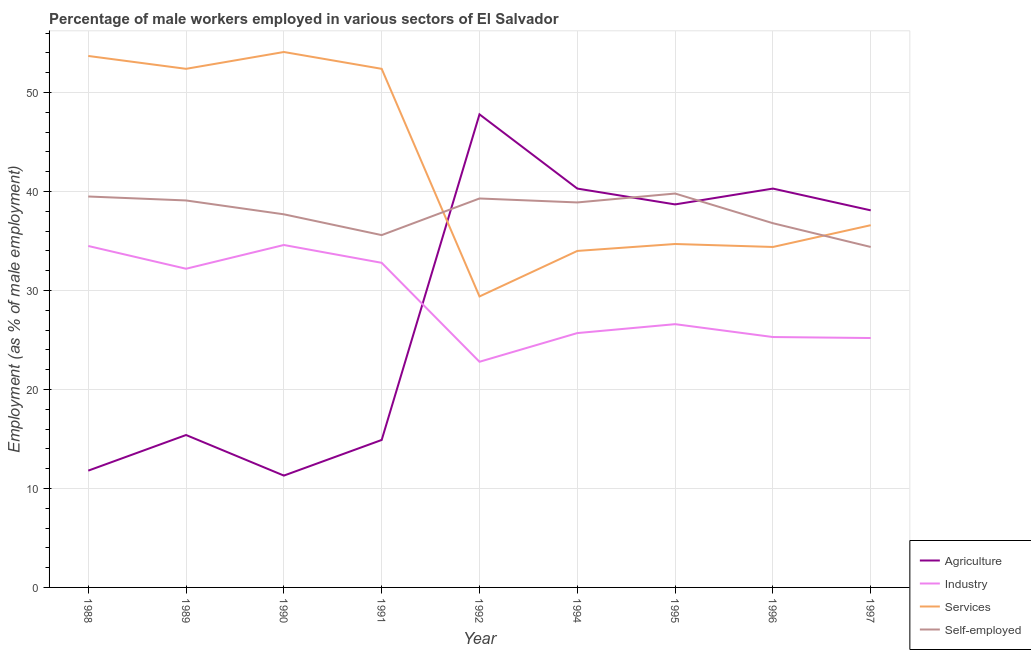How many different coloured lines are there?
Provide a succinct answer. 4. Does the line corresponding to percentage of male workers in services intersect with the line corresponding to percentage of self employed male workers?
Provide a short and direct response. Yes. Is the number of lines equal to the number of legend labels?
Offer a very short reply. Yes. What is the percentage of male workers in services in 1988?
Give a very brief answer. 53.7. Across all years, what is the maximum percentage of self employed male workers?
Provide a succinct answer. 39.8. Across all years, what is the minimum percentage of male workers in agriculture?
Provide a short and direct response. 11.3. In which year was the percentage of male workers in industry maximum?
Provide a short and direct response. 1990. In which year was the percentage of male workers in agriculture minimum?
Provide a succinct answer. 1990. What is the total percentage of self employed male workers in the graph?
Give a very brief answer. 341.1. What is the difference between the percentage of male workers in services in 1990 and that in 1996?
Offer a very short reply. 19.7. What is the difference between the percentage of male workers in agriculture in 1996 and the percentage of male workers in services in 1995?
Your response must be concise. 5.6. What is the average percentage of male workers in industry per year?
Make the answer very short. 28.86. In the year 1990, what is the difference between the percentage of self employed male workers and percentage of male workers in agriculture?
Offer a very short reply. 26.4. What is the ratio of the percentage of self employed male workers in 1991 to that in 1994?
Give a very brief answer. 0.92. What is the difference between the highest and the second highest percentage of male workers in services?
Provide a succinct answer. 0.4. What is the difference between the highest and the lowest percentage of male workers in services?
Give a very brief answer. 24.7. Is the sum of the percentage of male workers in industry in 1989 and 1996 greater than the maximum percentage of self employed male workers across all years?
Ensure brevity in your answer.  Yes. Is it the case that in every year, the sum of the percentage of self employed male workers and percentage of male workers in services is greater than the sum of percentage of male workers in industry and percentage of male workers in agriculture?
Your answer should be very brief. Yes. Does the percentage of male workers in services monotonically increase over the years?
Offer a very short reply. No. How many lines are there?
Ensure brevity in your answer.  4. Does the graph contain any zero values?
Provide a short and direct response. No. Does the graph contain grids?
Keep it short and to the point. Yes. Where does the legend appear in the graph?
Your answer should be compact. Bottom right. How many legend labels are there?
Offer a very short reply. 4. What is the title of the graph?
Your answer should be very brief. Percentage of male workers employed in various sectors of El Salvador. What is the label or title of the X-axis?
Your answer should be very brief. Year. What is the label or title of the Y-axis?
Your answer should be compact. Employment (as % of male employment). What is the Employment (as % of male employment) in Agriculture in 1988?
Your response must be concise. 11.8. What is the Employment (as % of male employment) in Industry in 1988?
Offer a terse response. 34.5. What is the Employment (as % of male employment) of Services in 1988?
Provide a short and direct response. 53.7. What is the Employment (as % of male employment) of Self-employed in 1988?
Give a very brief answer. 39.5. What is the Employment (as % of male employment) in Agriculture in 1989?
Your response must be concise. 15.4. What is the Employment (as % of male employment) in Industry in 1989?
Offer a very short reply. 32.2. What is the Employment (as % of male employment) of Services in 1989?
Your answer should be very brief. 52.4. What is the Employment (as % of male employment) in Self-employed in 1989?
Your response must be concise. 39.1. What is the Employment (as % of male employment) in Agriculture in 1990?
Keep it short and to the point. 11.3. What is the Employment (as % of male employment) in Industry in 1990?
Ensure brevity in your answer.  34.6. What is the Employment (as % of male employment) of Services in 1990?
Your answer should be very brief. 54.1. What is the Employment (as % of male employment) of Self-employed in 1990?
Offer a very short reply. 37.7. What is the Employment (as % of male employment) of Agriculture in 1991?
Your answer should be compact. 14.9. What is the Employment (as % of male employment) of Industry in 1991?
Make the answer very short. 32.8. What is the Employment (as % of male employment) of Services in 1991?
Give a very brief answer. 52.4. What is the Employment (as % of male employment) of Self-employed in 1991?
Offer a terse response. 35.6. What is the Employment (as % of male employment) of Agriculture in 1992?
Provide a succinct answer. 47.8. What is the Employment (as % of male employment) in Industry in 1992?
Provide a succinct answer. 22.8. What is the Employment (as % of male employment) of Services in 1992?
Your response must be concise. 29.4. What is the Employment (as % of male employment) in Self-employed in 1992?
Offer a terse response. 39.3. What is the Employment (as % of male employment) in Agriculture in 1994?
Make the answer very short. 40.3. What is the Employment (as % of male employment) of Industry in 1994?
Give a very brief answer. 25.7. What is the Employment (as % of male employment) in Services in 1994?
Give a very brief answer. 34. What is the Employment (as % of male employment) in Self-employed in 1994?
Your answer should be compact. 38.9. What is the Employment (as % of male employment) of Agriculture in 1995?
Provide a succinct answer. 38.7. What is the Employment (as % of male employment) of Industry in 1995?
Your response must be concise. 26.6. What is the Employment (as % of male employment) in Services in 1995?
Make the answer very short. 34.7. What is the Employment (as % of male employment) in Self-employed in 1995?
Provide a short and direct response. 39.8. What is the Employment (as % of male employment) of Agriculture in 1996?
Give a very brief answer. 40.3. What is the Employment (as % of male employment) of Industry in 1996?
Your answer should be compact. 25.3. What is the Employment (as % of male employment) in Services in 1996?
Make the answer very short. 34.4. What is the Employment (as % of male employment) in Self-employed in 1996?
Keep it short and to the point. 36.8. What is the Employment (as % of male employment) of Agriculture in 1997?
Make the answer very short. 38.1. What is the Employment (as % of male employment) of Industry in 1997?
Your answer should be compact. 25.2. What is the Employment (as % of male employment) in Services in 1997?
Make the answer very short. 36.6. What is the Employment (as % of male employment) of Self-employed in 1997?
Offer a very short reply. 34.4. Across all years, what is the maximum Employment (as % of male employment) in Agriculture?
Offer a terse response. 47.8. Across all years, what is the maximum Employment (as % of male employment) of Industry?
Provide a succinct answer. 34.6. Across all years, what is the maximum Employment (as % of male employment) in Services?
Ensure brevity in your answer.  54.1. Across all years, what is the maximum Employment (as % of male employment) in Self-employed?
Provide a succinct answer. 39.8. Across all years, what is the minimum Employment (as % of male employment) in Agriculture?
Your response must be concise. 11.3. Across all years, what is the minimum Employment (as % of male employment) of Industry?
Give a very brief answer. 22.8. Across all years, what is the minimum Employment (as % of male employment) of Services?
Provide a succinct answer. 29.4. Across all years, what is the minimum Employment (as % of male employment) in Self-employed?
Your response must be concise. 34.4. What is the total Employment (as % of male employment) in Agriculture in the graph?
Make the answer very short. 258.6. What is the total Employment (as % of male employment) in Industry in the graph?
Give a very brief answer. 259.7. What is the total Employment (as % of male employment) in Services in the graph?
Provide a short and direct response. 381.7. What is the total Employment (as % of male employment) in Self-employed in the graph?
Provide a short and direct response. 341.1. What is the difference between the Employment (as % of male employment) in Industry in 1988 and that in 1989?
Provide a succinct answer. 2.3. What is the difference between the Employment (as % of male employment) in Agriculture in 1988 and that in 1990?
Offer a very short reply. 0.5. What is the difference between the Employment (as % of male employment) of Services in 1988 and that in 1990?
Provide a short and direct response. -0.4. What is the difference between the Employment (as % of male employment) in Self-employed in 1988 and that in 1990?
Provide a succinct answer. 1.8. What is the difference between the Employment (as % of male employment) in Agriculture in 1988 and that in 1991?
Your answer should be compact. -3.1. What is the difference between the Employment (as % of male employment) of Industry in 1988 and that in 1991?
Keep it short and to the point. 1.7. What is the difference between the Employment (as % of male employment) in Services in 1988 and that in 1991?
Offer a very short reply. 1.3. What is the difference between the Employment (as % of male employment) of Self-employed in 1988 and that in 1991?
Provide a succinct answer. 3.9. What is the difference between the Employment (as % of male employment) in Agriculture in 1988 and that in 1992?
Your response must be concise. -36. What is the difference between the Employment (as % of male employment) in Industry in 1988 and that in 1992?
Provide a short and direct response. 11.7. What is the difference between the Employment (as % of male employment) in Services in 1988 and that in 1992?
Offer a terse response. 24.3. What is the difference between the Employment (as % of male employment) in Self-employed in 1988 and that in 1992?
Offer a terse response. 0.2. What is the difference between the Employment (as % of male employment) in Agriculture in 1988 and that in 1994?
Offer a terse response. -28.5. What is the difference between the Employment (as % of male employment) in Agriculture in 1988 and that in 1995?
Keep it short and to the point. -26.9. What is the difference between the Employment (as % of male employment) of Agriculture in 1988 and that in 1996?
Provide a short and direct response. -28.5. What is the difference between the Employment (as % of male employment) of Services in 1988 and that in 1996?
Make the answer very short. 19.3. What is the difference between the Employment (as % of male employment) in Agriculture in 1988 and that in 1997?
Make the answer very short. -26.3. What is the difference between the Employment (as % of male employment) of Services in 1988 and that in 1997?
Your answer should be very brief. 17.1. What is the difference between the Employment (as % of male employment) of Self-employed in 1988 and that in 1997?
Your answer should be very brief. 5.1. What is the difference between the Employment (as % of male employment) in Agriculture in 1989 and that in 1990?
Make the answer very short. 4.1. What is the difference between the Employment (as % of male employment) in Industry in 1989 and that in 1990?
Your response must be concise. -2.4. What is the difference between the Employment (as % of male employment) of Agriculture in 1989 and that in 1991?
Provide a succinct answer. 0.5. What is the difference between the Employment (as % of male employment) in Agriculture in 1989 and that in 1992?
Provide a short and direct response. -32.4. What is the difference between the Employment (as % of male employment) in Services in 1989 and that in 1992?
Keep it short and to the point. 23. What is the difference between the Employment (as % of male employment) in Agriculture in 1989 and that in 1994?
Give a very brief answer. -24.9. What is the difference between the Employment (as % of male employment) in Industry in 1989 and that in 1994?
Your answer should be compact. 6.5. What is the difference between the Employment (as % of male employment) of Services in 1989 and that in 1994?
Make the answer very short. 18.4. What is the difference between the Employment (as % of male employment) in Self-employed in 1989 and that in 1994?
Make the answer very short. 0.2. What is the difference between the Employment (as % of male employment) of Agriculture in 1989 and that in 1995?
Ensure brevity in your answer.  -23.3. What is the difference between the Employment (as % of male employment) of Industry in 1989 and that in 1995?
Make the answer very short. 5.6. What is the difference between the Employment (as % of male employment) in Services in 1989 and that in 1995?
Your response must be concise. 17.7. What is the difference between the Employment (as % of male employment) in Self-employed in 1989 and that in 1995?
Offer a terse response. -0.7. What is the difference between the Employment (as % of male employment) in Agriculture in 1989 and that in 1996?
Offer a very short reply. -24.9. What is the difference between the Employment (as % of male employment) in Agriculture in 1989 and that in 1997?
Give a very brief answer. -22.7. What is the difference between the Employment (as % of male employment) of Services in 1989 and that in 1997?
Make the answer very short. 15.8. What is the difference between the Employment (as % of male employment) of Agriculture in 1990 and that in 1991?
Keep it short and to the point. -3.6. What is the difference between the Employment (as % of male employment) in Industry in 1990 and that in 1991?
Your answer should be very brief. 1.8. What is the difference between the Employment (as % of male employment) in Services in 1990 and that in 1991?
Your answer should be very brief. 1.7. What is the difference between the Employment (as % of male employment) in Agriculture in 1990 and that in 1992?
Give a very brief answer. -36.5. What is the difference between the Employment (as % of male employment) in Services in 1990 and that in 1992?
Give a very brief answer. 24.7. What is the difference between the Employment (as % of male employment) of Self-employed in 1990 and that in 1992?
Your answer should be compact. -1.6. What is the difference between the Employment (as % of male employment) of Industry in 1990 and that in 1994?
Make the answer very short. 8.9. What is the difference between the Employment (as % of male employment) in Services in 1990 and that in 1994?
Give a very brief answer. 20.1. What is the difference between the Employment (as % of male employment) in Self-employed in 1990 and that in 1994?
Provide a short and direct response. -1.2. What is the difference between the Employment (as % of male employment) of Agriculture in 1990 and that in 1995?
Provide a short and direct response. -27.4. What is the difference between the Employment (as % of male employment) of Services in 1990 and that in 1995?
Give a very brief answer. 19.4. What is the difference between the Employment (as % of male employment) in Agriculture in 1990 and that in 1996?
Ensure brevity in your answer.  -29. What is the difference between the Employment (as % of male employment) of Services in 1990 and that in 1996?
Offer a very short reply. 19.7. What is the difference between the Employment (as % of male employment) of Agriculture in 1990 and that in 1997?
Offer a very short reply. -26.8. What is the difference between the Employment (as % of male employment) in Industry in 1990 and that in 1997?
Your answer should be compact. 9.4. What is the difference between the Employment (as % of male employment) of Agriculture in 1991 and that in 1992?
Give a very brief answer. -32.9. What is the difference between the Employment (as % of male employment) in Services in 1991 and that in 1992?
Your answer should be compact. 23. What is the difference between the Employment (as % of male employment) in Self-employed in 1991 and that in 1992?
Give a very brief answer. -3.7. What is the difference between the Employment (as % of male employment) of Agriculture in 1991 and that in 1994?
Give a very brief answer. -25.4. What is the difference between the Employment (as % of male employment) in Industry in 1991 and that in 1994?
Give a very brief answer. 7.1. What is the difference between the Employment (as % of male employment) in Agriculture in 1991 and that in 1995?
Your answer should be compact. -23.8. What is the difference between the Employment (as % of male employment) in Industry in 1991 and that in 1995?
Ensure brevity in your answer.  6.2. What is the difference between the Employment (as % of male employment) of Agriculture in 1991 and that in 1996?
Offer a terse response. -25.4. What is the difference between the Employment (as % of male employment) of Industry in 1991 and that in 1996?
Offer a terse response. 7.5. What is the difference between the Employment (as % of male employment) of Services in 1991 and that in 1996?
Provide a short and direct response. 18. What is the difference between the Employment (as % of male employment) in Agriculture in 1991 and that in 1997?
Keep it short and to the point. -23.2. What is the difference between the Employment (as % of male employment) of Agriculture in 1992 and that in 1994?
Provide a succinct answer. 7.5. What is the difference between the Employment (as % of male employment) of Self-employed in 1992 and that in 1994?
Your answer should be very brief. 0.4. What is the difference between the Employment (as % of male employment) in Agriculture in 1992 and that in 1995?
Your answer should be compact. 9.1. What is the difference between the Employment (as % of male employment) in Industry in 1992 and that in 1995?
Your response must be concise. -3.8. What is the difference between the Employment (as % of male employment) of Self-employed in 1992 and that in 1995?
Ensure brevity in your answer.  -0.5. What is the difference between the Employment (as % of male employment) in Agriculture in 1992 and that in 1996?
Your answer should be very brief. 7.5. What is the difference between the Employment (as % of male employment) of Industry in 1992 and that in 1997?
Keep it short and to the point. -2.4. What is the difference between the Employment (as % of male employment) in Services in 1992 and that in 1997?
Provide a short and direct response. -7.2. What is the difference between the Employment (as % of male employment) of Industry in 1994 and that in 1995?
Give a very brief answer. -0.9. What is the difference between the Employment (as % of male employment) of Services in 1994 and that in 1995?
Your answer should be compact. -0.7. What is the difference between the Employment (as % of male employment) of Self-employed in 1994 and that in 1996?
Make the answer very short. 2.1. What is the difference between the Employment (as % of male employment) in Agriculture in 1994 and that in 1997?
Make the answer very short. 2.2. What is the difference between the Employment (as % of male employment) of Services in 1994 and that in 1997?
Keep it short and to the point. -2.6. What is the difference between the Employment (as % of male employment) in Self-employed in 1994 and that in 1997?
Provide a succinct answer. 4.5. What is the difference between the Employment (as % of male employment) of Agriculture in 1995 and that in 1996?
Ensure brevity in your answer.  -1.6. What is the difference between the Employment (as % of male employment) of Industry in 1995 and that in 1996?
Your answer should be compact. 1.3. What is the difference between the Employment (as % of male employment) of Self-employed in 1995 and that in 1996?
Give a very brief answer. 3. What is the difference between the Employment (as % of male employment) of Industry in 1995 and that in 1997?
Offer a very short reply. 1.4. What is the difference between the Employment (as % of male employment) of Industry in 1996 and that in 1997?
Your answer should be compact. 0.1. What is the difference between the Employment (as % of male employment) in Self-employed in 1996 and that in 1997?
Your answer should be compact. 2.4. What is the difference between the Employment (as % of male employment) of Agriculture in 1988 and the Employment (as % of male employment) of Industry in 1989?
Your answer should be compact. -20.4. What is the difference between the Employment (as % of male employment) in Agriculture in 1988 and the Employment (as % of male employment) in Services in 1989?
Offer a terse response. -40.6. What is the difference between the Employment (as % of male employment) in Agriculture in 1988 and the Employment (as % of male employment) in Self-employed in 1989?
Ensure brevity in your answer.  -27.3. What is the difference between the Employment (as % of male employment) of Industry in 1988 and the Employment (as % of male employment) of Services in 1989?
Give a very brief answer. -17.9. What is the difference between the Employment (as % of male employment) in Industry in 1988 and the Employment (as % of male employment) in Self-employed in 1989?
Make the answer very short. -4.6. What is the difference between the Employment (as % of male employment) in Services in 1988 and the Employment (as % of male employment) in Self-employed in 1989?
Ensure brevity in your answer.  14.6. What is the difference between the Employment (as % of male employment) in Agriculture in 1988 and the Employment (as % of male employment) in Industry in 1990?
Keep it short and to the point. -22.8. What is the difference between the Employment (as % of male employment) in Agriculture in 1988 and the Employment (as % of male employment) in Services in 1990?
Provide a succinct answer. -42.3. What is the difference between the Employment (as % of male employment) of Agriculture in 1988 and the Employment (as % of male employment) of Self-employed in 1990?
Offer a very short reply. -25.9. What is the difference between the Employment (as % of male employment) in Industry in 1988 and the Employment (as % of male employment) in Services in 1990?
Make the answer very short. -19.6. What is the difference between the Employment (as % of male employment) of Industry in 1988 and the Employment (as % of male employment) of Self-employed in 1990?
Your answer should be compact. -3.2. What is the difference between the Employment (as % of male employment) in Services in 1988 and the Employment (as % of male employment) in Self-employed in 1990?
Your answer should be very brief. 16. What is the difference between the Employment (as % of male employment) of Agriculture in 1988 and the Employment (as % of male employment) of Services in 1991?
Keep it short and to the point. -40.6. What is the difference between the Employment (as % of male employment) in Agriculture in 1988 and the Employment (as % of male employment) in Self-employed in 1991?
Provide a short and direct response. -23.8. What is the difference between the Employment (as % of male employment) in Industry in 1988 and the Employment (as % of male employment) in Services in 1991?
Ensure brevity in your answer.  -17.9. What is the difference between the Employment (as % of male employment) in Industry in 1988 and the Employment (as % of male employment) in Self-employed in 1991?
Offer a very short reply. -1.1. What is the difference between the Employment (as % of male employment) of Services in 1988 and the Employment (as % of male employment) of Self-employed in 1991?
Ensure brevity in your answer.  18.1. What is the difference between the Employment (as % of male employment) in Agriculture in 1988 and the Employment (as % of male employment) in Industry in 1992?
Your answer should be compact. -11. What is the difference between the Employment (as % of male employment) of Agriculture in 1988 and the Employment (as % of male employment) of Services in 1992?
Offer a very short reply. -17.6. What is the difference between the Employment (as % of male employment) of Agriculture in 1988 and the Employment (as % of male employment) of Self-employed in 1992?
Make the answer very short. -27.5. What is the difference between the Employment (as % of male employment) of Industry in 1988 and the Employment (as % of male employment) of Self-employed in 1992?
Offer a very short reply. -4.8. What is the difference between the Employment (as % of male employment) in Services in 1988 and the Employment (as % of male employment) in Self-employed in 1992?
Offer a terse response. 14.4. What is the difference between the Employment (as % of male employment) in Agriculture in 1988 and the Employment (as % of male employment) in Services in 1994?
Your response must be concise. -22.2. What is the difference between the Employment (as % of male employment) of Agriculture in 1988 and the Employment (as % of male employment) of Self-employed in 1994?
Keep it short and to the point. -27.1. What is the difference between the Employment (as % of male employment) of Industry in 1988 and the Employment (as % of male employment) of Self-employed in 1994?
Your answer should be compact. -4.4. What is the difference between the Employment (as % of male employment) of Agriculture in 1988 and the Employment (as % of male employment) of Industry in 1995?
Make the answer very short. -14.8. What is the difference between the Employment (as % of male employment) of Agriculture in 1988 and the Employment (as % of male employment) of Services in 1995?
Ensure brevity in your answer.  -22.9. What is the difference between the Employment (as % of male employment) of Agriculture in 1988 and the Employment (as % of male employment) of Self-employed in 1995?
Your answer should be compact. -28. What is the difference between the Employment (as % of male employment) of Industry in 1988 and the Employment (as % of male employment) of Services in 1995?
Offer a terse response. -0.2. What is the difference between the Employment (as % of male employment) of Agriculture in 1988 and the Employment (as % of male employment) of Industry in 1996?
Offer a very short reply. -13.5. What is the difference between the Employment (as % of male employment) of Agriculture in 1988 and the Employment (as % of male employment) of Services in 1996?
Keep it short and to the point. -22.6. What is the difference between the Employment (as % of male employment) in Agriculture in 1988 and the Employment (as % of male employment) in Self-employed in 1996?
Your answer should be compact. -25. What is the difference between the Employment (as % of male employment) of Industry in 1988 and the Employment (as % of male employment) of Services in 1996?
Your response must be concise. 0.1. What is the difference between the Employment (as % of male employment) of Services in 1988 and the Employment (as % of male employment) of Self-employed in 1996?
Your answer should be very brief. 16.9. What is the difference between the Employment (as % of male employment) in Agriculture in 1988 and the Employment (as % of male employment) in Industry in 1997?
Provide a succinct answer. -13.4. What is the difference between the Employment (as % of male employment) in Agriculture in 1988 and the Employment (as % of male employment) in Services in 1997?
Your answer should be very brief. -24.8. What is the difference between the Employment (as % of male employment) of Agriculture in 1988 and the Employment (as % of male employment) of Self-employed in 1997?
Offer a terse response. -22.6. What is the difference between the Employment (as % of male employment) of Services in 1988 and the Employment (as % of male employment) of Self-employed in 1997?
Provide a succinct answer. 19.3. What is the difference between the Employment (as % of male employment) of Agriculture in 1989 and the Employment (as % of male employment) of Industry in 1990?
Make the answer very short. -19.2. What is the difference between the Employment (as % of male employment) of Agriculture in 1989 and the Employment (as % of male employment) of Services in 1990?
Give a very brief answer. -38.7. What is the difference between the Employment (as % of male employment) in Agriculture in 1989 and the Employment (as % of male employment) in Self-employed in 1990?
Your answer should be compact. -22.3. What is the difference between the Employment (as % of male employment) of Industry in 1989 and the Employment (as % of male employment) of Services in 1990?
Provide a short and direct response. -21.9. What is the difference between the Employment (as % of male employment) in Industry in 1989 and the Employment (as % of male employment) in Self-employed in 1990?
Provide a short and direct response. -5.5. What is the difference between the Employment (as % of male employment) in Services in 1989 and the Employment (as % of male employment) in Self-employed in 1990?
Ensure brevity in your answer.  14.7. What is the difference between the Employment (as % of male employment) of Agriculture in 1989 and the Employment (as % of male employment) of Industry in 1991?
Provide a succinct answer. -17.4. What is the difference between the Employment (as % of male employment) in Agriculture in 1989 and the Employment (as % of male employment) in Services in 1991?
Your answer should be compact. -37. What is the difference between the Employment (as % of male employment) in Agriculture in 1989 and the Employment (as % of male employment) in Self-employed in 1991?
Keep it short and to the point. -20.2. What is the difference between the Employment (as % of male employment) of Industry in 1989 and the Employment (as % of male employment) of Services in 1991?
Your response must be concise. -20.2. What is the difference between the Employment (as % of male employment) of Industry in 1989 and the Employment (as % of male employment) of Self-employed in 1991?
Offer a very short reply. -3.4. What is the difference between the Employment (as % of male employment) of Agriculture in 1989 and the Employment (as % of male employment) of Industry in 1992?
Your response must be concise. -7.4. What is the difference between the Employment (as % of male employment) in Agriculture in 1989 and the Employment (as % of male employment) in Services in 1992?
Keep it short and to the point. -14. What is the difference between the Employment (as % of male employment) of Agriculture in 1989 and the Employment (as % of male employment) of Self-employed in 1992?
Keep it short and to the point. -23.9. What is the difference between the Employment (as % of male employment) of Industry in 1989 and the Employment (as % of male employment) of Self-employed in 1992?
Give a very brief answer. -7.1. What is the difference between the Employment (as % of male employment) of Agriculture in 1989 and the Employment (as % of male employment) of Services in 1994?
Make the answer very short. -18.6. What is the difference between the Employment (as % of male employment) in Agriculture in 1989 and the Employment (as % of male employment) in Self-employed in 1994?
Ensure brevity in your answer.  -23.5. What is the difference between the Employment (as % of male employment) of Industry in 1989 and the Employment (as % of male employment) of Self-employed in 1994?
Your response must be concise. -6.7. What is the difference between the Employment (as % of male employment) of Services in 1989 and the Employment (as % of male employment) of Self-employed in 1994?
Ensure brevity in your answer.  13.5. What is the difference between the Employment (as % of male employment) in Agriculture in 1989 and the Employment (as % of male employment) in Industry in 1995?
Make the answer very short. -11.2. What is the difference between the Employment (as % of male employment) of Agriculture in 1989 and the Employment (as % of male employment) of Services in 1995?
Ensure brevity in your answer.  -19.3. What is the difference between the Employment (as % of male employment) of Agriculture in 1989 and the Employment (as % of male employment) of Self-employed in 1995?
Ensure brevity in your answer.  -24.4. What is the difference between the Employment (as % of male employment) in Industry in 1989 and the Employment (as % of male employment) in Services in 1995?
Make the answer very short. -2.5. What is the difference between the Employment (as % of male employment) of Industry in 1989 and the Employment (as % of male employment) of Self-employed in 1995?
Keep it short and to the point. -7.6. What is the difference between the Employment (as % of male employment) of Services in 1989 and the Employment (as % of male employment) of Self-employed in 1995?
Offer a terse response. 12.6. What is the difference between the Employment (as % of male employment) of Agriculture in 1989 and the Employment (as % of male employment) of Self-employed in 1996?
Provide a succinct answer. -21.4. What is the difference between the Employment (as % of male employment) in Industry in 1989 and the Employment (as % of male employment) in Services in 1996?
Your response must be concise. -2.2. What is the difference between the Employment (as % of male employment) in Agriculture in 1989 and the Employment (as % of male employment) in Services in 1997?
Make the answer very short. -21.2. What is the difference between the Employment (as % of male employment) in Agriculture in 1989 and the Employment (as % of male employment) in Self-employed in 1997?
Give a very brief answer. -19. What is the difference between the Employment (as % of male employment) in Agriculture in 1990 and the Employment (as % of male employment) in Industry in 1991?
Offer a very short reply. -21.5. What is the difference between the Employment (as % of male employment) in Agriculture in 1990 and the Employment (as % of male employment) in Services in 1991?
Your answer should be compact. -41.1. What is the difference between the Employment (as % of male employment) in Agriculture in 1990 and the Employment (as % of male employment) in Self-employed in 1991?
Your answer should be very brief. -24.3. What is the difference between the Employment (as % of male employment) in Industry in 1990 and the Employment (as % of male employment) in Services in 1991?
Your response must be concise. -17.8. What is the difference between the Employment (as % of male employment) of Services in 1990 and the Employment (as % of male employment) of Self-employed in 1991?
Offer a terse response. 18.5. What is the difference between the Employment (as % of male employment) of Agriculture in 1990 and the Employment (as % of male employment) of Industry in 1992?
Make the answer very short. -11.5. What is the difference between the Employment (as % of male employment) in Agriculture in 1990 and the Employment (as % of male employment) in Services in 1992?
Offer a terse response. -18.1. What is the difference between the Employment (as % of male employment) in Agriculture in 1990 and the Employment (as % of male employment) in Self-employed in 1992?
Offer a terse response. -28. What is the difference between the Employment (as % of male employment) of Industry in 1990 and the Employment (as % of male employment) of Services in 1992?
Offer a terse response. 5.2. What is the difference between the Employment (as % of male employment) in Agriculture in 1990 and the Employment (as % of male employment) in Industry in 1994?
Your response must be concise. -14.4. What is the difference between the Employment (as % of male employment) in Agriculture in 1990 and the Employment (as % of male employment) in Services in 1994?
Give a very brief answer. -22.7. What is the difference between the Employment (as % of male employment) in Agriculture in 1990 and the Employment (as % of male employment) in Self-employed in 1994?
Offer a terse response. -27.6. What is the difference between the Employment (as % of male employment) in Industry in 1990 and the Employment (as % of male employment) in Services in 1994?
Make the answer very short. 0.6. What is the difference between the Employment (as % of male employment) in Industry in 1990 and the Employment (as % of male employment) in Self-employed in 1994?
Your response must be concise. -4.3. What is the difference between the Employment (as % of male employment) in Services in 1990 and the Employment (as % of male employment) in Self-employed in 1994?
Ensure brevity in your answer.  15.2. What is the difference between the Employment (as % of male employment) in Agriculture in 1990 and the Employment (as % of male employment) in Industry in 1995?
Keep it short and to the point. -15.3. What is the difference between the Employment (as % of male employment) of Agriculture in 1990 and the Employment (as % of male employment) of Services in 1995?
Your response must be concise. -23.4. What is the difference between the Employment (as % of male employment) of Agriculture in 1990 and the Employment (as % of male employment) of Self-employed in 1995?
Give a very brief answer. -28.5. What is the difference between the Employment (as % of male employment) in Industry in 1990 and the Employment (as % of male employment) in Services in 1995?
Ensure brevity in your answer.  -0.1. What is the difference between the Employment (as % of male employment) of Industry in 1990 and the Employment (as % of male employment) of Self-employed in 1995?
Make the answer very short. -5.2. What is the difference between the Employment (as % of male employment) in Agriculture in 1990 and the Employment (as % of male employment) in Industry in 1996?
Offer a terse response. -14. What is the difference between the Employment (as % of male employment) in Agriculture in 1990 and the Employment (as % of male employment) in Services in 1996?
Your response must be concise. -23.1. What is the difference between the Employment (as % of male employment) in Agriculture in 1990 and the Employment (as % of male employment) in Self-employed in 1996?
Your answer should be very brief. -25.5. What is the difference between the Employment (as % of male employment) of Industry in 1990 and the Employment (as % of male employment) of Services in 1996?
Offer a very short reply. 0.2. What is the difference between the Employment (as % of male employment) in Agriculture in 1990 and the Employment (as % of male employment) in Industry in 1997?
Offer a very short reply. -13.9. What is the difference between the Employment (as % of male employment) of Agriculture in 1990 and the Employment (as % of male employment) of Services in 1997?
Provide a short and direct response. -25.3. What is the difference between the Employment (as % of male employment) of Agriculture in 1990 and the Employment (as % of male employment) of Self-employed in 1997?
Ensure brevity in your answer.  -23.1. What is the difference between the Employment (as % of male employment) of Services in 1990 and the Employment (as % of male employment) of Self-employed in 1997?
Ensure brevity in your answer.  19.7. What is the difference between the Employment (as % of male employment) in Agriculture in 1991 and the Employment (as % of male employment) in Industry in 1992?
Offer a very short reply. -7.9. What is the difference between the Employment (as % of male employment) of Agriculture in 1991 and the Employment (as % of male employment) of Services in 1992?
Offer a very short reply. -14.5. What is the difference between the Employment (as % of male employment) of Agriculture in 1991 and the Employment (as % of male employment) of Self-employed in 1992?
Offer a terse response. -24.4. What is the difference between the Employment (as % of male employment) of Industry in 1991 and the Employment (as % of male employment) of Self-employed in 1992?
Your answer should be very brief. -6.5. What is the difference between the Employment (as % of male employment) of Agriculture in 1991 and the Employment (as % of male employment) of Services in 1994?
Offer a very short reply. -19.1. What is the difference between the Employment (as % of male employment) of Agriculture in 1991 and the Employment (as % of male employment) of Self-employed in 1994?
Give a very brief answer. -24. What is the difference between the Employment (as % of male employment) of Industry in 1991 and the Employment (as % of male employment) of Services in 1994?
Keep it short and to the point. -1.2. What is the difference between the Employment (as % of male employment) of Industry in 1991 and the Employment (as % of male employment) of Self-employed in 1994?
Make the answer very short. -6.1. What is the difference between the Employment (as % of male employment) in Services in 1991 and the Employment (as % of male employment) in Self-employed in 1994?
Your answer should be very brief. 13.5. What is the difference between the Employment (as % of male employment) in Agriculture in 1991 and the Employment (as % of male employment) in Services in 1995?
Make the answer very short. -19.8. What is the difference between the Employment (as % of male employment) in Agriculture in 1991 and the Employment (as % of male employment) in Self-employed in 1995?
Your answer should be compact. -24.9. What is the difference between the Employment (as % of male employment) in Industry in 1991 and the Employment (as % of male employment) in Self-employed in 1995?
Provide a short and direct response. -7. What is the difference between the Employment (as % of male employment) in Services in 1991 and the Employment (as % of male employment) in Self-employed in 1995?
Provide a succinct answer. 12.6. What is the difference between the Employment (as % of male employment) in Agriculture in 1991 and the Employment (as % of male employment) in Services in 1996?
Your answer should be very brief. -19.5. What is the difference between the Employment (as % of male employment) in Agriculture in 1991 and the Employment (as % of male employment) in Self-employed in 1996?
Give a very brief answer. -21.9. What is the difference between the Employment (as % of male employment) in Services in 1991 and the Employment (as % of male employment) in Self-employed in 1996?
Your answer should be compact. 15.6. What is the difference between the Employment (as % of male employment) of Agriculture in 1991 and the Employment (as % of male employment) of Services in 1997?
Your response must be concise. -21.7. What is the difference between the Employment (as % of male employment) of Agriculture in 1991 and the Employment (as % of male employment) of Self-employed in 1997?
Offer a terse response. -19.5. What is the difference between the Employment (as % of male employment) in Services in 1991 and the Employment (as % of male employment) in Self-employed in 1997?
Give a very brief answer. 18. What is the difference between the Employment (as % of male employment) of Agriculture in 1992 and the Employment (as % of male employment) of Industry in 1994?
Make the answer very short. 22.1. What is the difference between the Employment (as % of male employment) of Agriculture in 1992 and the Employment (as % of male employment) of Services in 1994?
Provide a succinct answer. 13.8. What is the difference between the Employment (as % of male employment) of Industry in 1992 and the Employment (as % of male employment) of Services in 1994?
Keep it short and to the point. -11.2. What is the difference between the Employment (as % of male employment) in Industry in 1992 and the Employment (as % of male employment) in Self-employed in 1994?
Give a very brief answer. -16.1. What is the difference between the Employment (as % of male employment) of Agriculture in 1992 and the Employment (as % of male employment) of Industry in 1995?
Keep it short and to the point. 21.2. What is the difference between the Employment (as % of male employment) in Industry in 1992 and the Employment (as % of male employment) in Services in 1995?
Make the answer very short. -11.9. What is the difference between the Employment (as % of male employment) in Industry in 1992 and the Employment (as % of male employment) in Self-employed in 1995?
Your response must be concise. -17. What is the difference between the Employment (as % of male employment) of Agriculture in 1992 and the Employment (as % of male employment) of Industry in 1996?
Provide a succinct answer. 22.5. What is the difference between the Employment (as % of male employment) in Agriculture in 1992 and the Employment (as % of male employment) in Services in 1996?
Your answer should be very brief. 13.4. What is the difference between the Employment (as % of male employment) in Industry in 1992 and the Employment (as % of male employment) in Services in 1996?
Give a very brief answer. -11.6. What is the difference between the Employment (as % of male employment) in Industry in 1992 and the Employment (as % of male employment) in Self-employed in 1996?
Your answer should be very brief. -14. What is the difference between the Employment (as % of male employment) of Agriculture in 1992 and the Employment (as % of male employment) of Industry in 1997?
Give a very brief answer. 22.6. What is the difference between the Employment (as % of male employment) in Industry in 1994 and the Employment (as % of male employment) in Self-employed in 1995?
Keep it short and to the point. -14.1. What is the difference between the Employment (as % of male employment) in Agriculture in 1994 and the Employment (as % of male employment) in Self-employed in 1996?
Ensure brevity in your answer.  3.5. What is the difference between the Employment (as % of male employment) of Industry in 1994 and the Employment (as % of male employment) of Self-employed in 1996?
Your answer should be very brief. -11.1. What is the difference between the Employment (as % of male employment) of Services in 1994 and the Employment (as % of male employment) of Self-employed in 1996?
Keep it short and to the point. -2.8. What is the difference between the Employment (as % of male employment) of Agriculture in 1994 and the Employment (as % of male employment) of Industry in 1997?
Ensure brevity in your answer.  15.1. What is the difference between the Employment (as % of male employment) in Agriculture in 1994 and the Employment (as % of male employment) in Services in 1997?
Offer a terse response. 3.7. What is the difference between the Employment (as % of male employment) in Industry in 1994 and the Employment (as % of male employment) in Self-employed in 1997?
Your answer should be compact. -8.7. What is the difference between the Employment (as % of male employment) of Services in 1994 and the Employment (as % of male employment) of Self-employed in 1997?
Keep it short and to the point. -0.4. What is the difference between the Employment (as % of male employment) of Agriculture in 1995 and the Employment (as % of male employment) of Services in 1996?
Your answer should be very brief. 4.3. What is the difference between the Employment (as % of male employment) in Agriculture in 1995 and the Employment (as % of male employment) in Self-employed in 1996?
Ensure brevity in your answer.  1.9. What is the difference between the Employment (as % of male employment) of Industry in 1995 and the Employment (as % of male employment) of Services in 1996?
Offer a terse response. -7.8. What is the difference between the Employment (as % of male employment) of Industry in 1995 and the Employment (as % of male employment) of Self-employed in 1996?
Make the answer very short. -10.2. What is the difference between the Employment (as % of male employment) in Services in 1995 and the Employment (as % of male employment) in Self-employed in 1996?
Give a very brief answer. -2.1. What is the difference between the Employment (as % of male employment) in Agriculture in 1995 and the Employment (as % of male employment) in Industry in 1997?
Offer a very short reply. 13.5. What is the difference between the Employment (as % of male employment) of Industry in 1995 and the Employment (as % of male employment) of Self-employed in 1997?
Your response must be concise. -7.8. What is the difference between the Employment (as % of male employment) in Services in 1995 and the Employment (as % of male employment) in Self-employed in 1997?
Keep it short and to the point. 0.3. What is the difference between the Employment (as % of male employment) in Agriculture in 1996 and the Employment (as % of male employment) in Industry in 1997?
Give a very brief answer. 15.1. What is the difference between the Employment (as % of male employment) of Services in 1996 and the Employment (as % of male employment) of Self-employed in 1997?
Your answer should be very brief. 0. What is the average Employment (as % of male employment) of Agriculture per year?
Keep it short and to the point. 28.73. What is the average Employment (as % of male employment) in Industry per year?
Make the answer very short. 28.86. What is the average Employment (as % of male employment) of Services per year?
Offer a very short reply. 42.41. What is the average Employment (as % of male employment) in Self-employed per year?
Make the answer very short. 37.9. In the year 1988, what is the difference between the Employment (as % of male employment) of Agriculture and Employment (as % of male employment) of Industry?
Provide a succinct answer. -22.7. In the year 1988, what is the difference between the Employment (as % of male employment) in Agriculture and Employment (as % of male employment) in Services?
Your answer should be compact. -41.9. In the year 1988, what is the difference between the Employment (as % of male employment) of Agriculture and Employment (as % of male employment) of Self-employed?
Your answer should be compact. -27.7. In the year 1988, what is the difference between the Employment (as % of male employment) of Industry and Employment (as % of male employment) of Services?
Your answer should be compact. -19.2. In the year 1988, what is the difference between the Employment (as % of male employment) in Industry and Employment (as % of male employment) in Self-employed?
Offer a terse response. -5. In the year 1988, what is the difference between the Employment (as % of male employment) in Services and Employment (as % of male employment) in Self-employed?
Your answer should be very brief. 14.2. In the year 1989, what is the difference between the Employment (as % of male employment) in Agriculture and Employment (as % of male employment) in Industry?
Provide a short and direct response. -16.8. In the year 1989, what is the difference between the Employment (as % of male employment) in Agriculture and Employment (as % of male employment) in Services?
Provide a short and direct response. -37. In the year 1989, what is the difference between the Employment (as % of male employment) of Agriculture and Employment (as % of male employment) of Self-employed?
Your answer should be very brief. -23.7. In the year 1989, what is the difference between the Employment (as % of male employment) of Industry and Employment (as % of male employment) of Services?
Provide a short and direct response. -20.2. In the year 1989, what is the difference between the Employment (as % of male employment) in Industry and Employment (as % of male employment) in Self-employed?
Keep it short and to the point. -6.9. In the year 1990, what is the difference between the Employment (as % of male employment) of Agriculture and Employment (as % of male employment) of Industry?
Your answer should be compact. -23.3. In the year 1990, what is the difference between the Employment (as % of male employment) of Agriculture and Employment (as % of male employment) of Services?
Your response must be concise. -42.8. In the year 1990, what is the difference between the Employment (as % of male employment) of Agriculture and Employment (as % of male employment) of Self-employed?
Your response must be concise. -26.4. In the year 1990, what is the difference between the Employment (as % of male employment) in Industry and Employment (as % of male employment) in Services?
Make the answer very short. -19.5. In the year 1991, what is the difference between the Employment (as % of male employment) of Agriculture and Employment (as % of male employment) of Industry?
Offer a terse response. -17.9. In the year 1991, what is the difference between the Employment (as % of male employment) of Agriculture and Employment (as % of male employment) of Services?
Provide a succinct answer. -37.5. In the year 1991, what is the difference between the Employment (as % of male employment) in Agriculture and Employment (as % of male employment) in Self-employed?
Your answer should be compact. -20.7. In the year 1991, what is the difference between the Employment (as % of male employment) of Industry and Employment (as % of male employment) of Services?
Make the answer very short. -19.6. In the year 1992, what is the difference between the Employment (as % of male employment) of Agriculture and Employment (as % of male employment) of Industry?
Ensure brevity in your answer.  25. In the year 1992, what is the difference between the Employment (as % of male employment) of Agriculture and Employment (as % of male employment) of Self-employed?
Provide a short and direct response. 8.5. In the year 1992, what is the difference between the Employment (as % of male employment) of Industry and Employment (as % of male employment) of Services?
Provide a succinct answer. -6.6. In the year 1992, what is the difference between the Employment (as % of male employment) in Industry and Employment (as % of male employment) in Self-employed?
Offer a terse response. -16.5. In the year 1994, what is the difference between the Employment (as % of male employment) of Agriculture and Employment (as % of male employment) of Industry?
Give a very brief answer. 14.6. In the year 1994, what is the difference between the Employment (as % of male employment) of Agriculture and Employment (as % of male employment) of Services?
Make the answer very short. 6.3. In the year 1994, what is the difference between the Employment (as % of male employment) in Agriculture and Employment (as % of male employment) in Self-employed?
Offer a very short reply. 1.4. In the year 1994, what is the difference between the Employment (as % of male employment) of Industry and Employment (as % of male employment) of Services?
Keep it short and to the point. -8.3. In the year 1994, what is the difference between the Employment (as % of male employment) in Services and Employment (as % of male employment) in Self-employed?
Keep it short and to the point. -4.9. In the year 1995, what is the difference between the Employment (as % of male employment) in Agriculture and Employment (as % of male employment) in Services?
Give a very brief answer. 4. In the year 1995, what is the difference between the Employment (as % of male employment) in Industry and Employment (as % of male employment) in Self-employed?
Ensure brevity in your answer.  -13.2. In the year 1995, what is the difference between the Employment (as % of male employment) in Services and Employment (as % of male employment) in Self-employed?
Offer a terse response. -5.1. In the year 1996, what is the difference between the Employment (as % of male employment) of Agriculture and Employment (as % of male employment) of Self-employed?
Keep it short and to the point. 3.5. In the year 1996, what is the difference between the Employment (as % of male employment) of Industry and Employment (as % of male employment) of Services?
Keep it short and to the point. -9.1. In the year 1997, what is the difference between the Employment (as % of male employment) of Agriculture and Employment (as % of male employment) of Services?
Your answer should be compact. 1.5. In the year 1997, what is the difference between the Employment (as % of male employment) in Agriculture and Employment (as % of male employment) in Self-employed?
Your response must be concise. 3.7. In the year 1997, what is the difference between the Employment (as % of male employment) in Industry and Employment (as % of male employment) in Services?
Offer a terse response. -11.4. What is the ratio of the Employment (as % of male employment) of Agriculture in 1988 to that in 1989?
Keep it short and to the point. 0.77. What is the ratio of the Employment (as % of male employment) in Industry in 1988 to that in 1989?
Your answer should be very brief. 1.07. What is the ratio of the Employment (as % of male employment) of Services in 1988 to that in 1989?
Make the answer very short. 1.02. What is the ratio of the Employment (as % of male employment) in Self-employed in 1988 to that in 1989?
Make the answer very short. 1.01. What is the ratio of the Employment (as % of male employment) in Agriculture in 1988 to that in 1990?
Provide a succinct answer. 1.04. What is the ratio of the Employment (as % of male employment) of Self-employed in 1988 to that in 1990?
Your response must be concise. 1.05. What is the ratio of the Employment (as % of male employment) in Agriculture in 1988 to that in 1991?
Ensure brevity in your answer.  0.79. What is the ratio of the Employment (as % of male employment) in Industry in 1988 to that in 1991?
Offer a terse response. 1.05. What is the ratio of the Employment (as % of male employment) of Services in 1988 to that in 1991?
Offer a terse response. 1.02. What is the ratio of the Employment (as % of male employment) of Self-employed in 1988 to that in 1991?
Your answer should be very brief. 1.11. What is the ratio of the Employment (as % of male employment) in Agriculture in 1988 to that in 1992?
Provide a succinct answer. 0.25. What is the ratio of the Employment (as % of male employment) in Industry in 1988 to that in 1992?
Your answer should be compact. 1.51. What is the ratio of the Employment (as % of male employment) in Services in 1988 to that in 1992?
Offer a very short reply. 1.83. What is the ratio of the Employment (as % of male employment) in Agriculture in 1988 to that in 1994?
Provide a succinct answer. 0.29. What is the ratio of the Employment (as % of male employment) of Industry in 1988 to that in 1994?
Provide a succinct answer. 1.34. What is the ratio of the Employment (as % of male employment) of Services in 1988 to that in 1994?
Ensure brevity in your answer.  1.58. What is the ratio of the Employment (as % of male employment) of Self-employed in 1988 to that in 1994?
Make the answer very short. 1.02. What is the ratio of the Employment (as % of male employment) in Agriculture in 1988 to that in 1995?
Make the answer very short. 0.3. What is the ratio of the Employment (as % of male employment) of Industry in 1988 to that in 1995?
Provide a succinct answer. 1.3. What is the ratio of the Employment (as % of male employment) of Services in 1988 to that in 1995?
Make the answer very short. 1.55. What is the ratio of the Employment (as % of male employment) in Self-employed in 1988 to that in 1995?
Your answer should be compact. 0.99. What is the ratio of the Employment (as % of male employment) of Agriculture in 1988 to that in 1996?
Give a very brief answer. 0.29. What is the ratio of the Employment (as % of male employment) in Industry in 1988 to that in 1996?
Ensure brevity in your answer.  1.36. What is the ratio of the Employment (as % of male employment) in Services in 1988 to that in 1996?
Provide a short and direct response. 1.56. What is the ratio of the Employment (as % of male employment) of Self-employed in 1988 to that in 1996?
Your response must be concise. 1.07. What is the ratio of the Employment (as % of male employment) in Agriculture in 1988 to that in 1997?
Make the answer very short. 0.31. What is the ratio of the Employment (as % of male employment) of Industry in 1988 to that in 1997?
Your response must be concise. 1.37. What is the ratio of the Employment (as % of male employment) of Services in 1988 to that in 1997?
Offer a very short reply. 1.47. What is the ratio of the Employment (as % of male employment) in Self-employed in 1988 to that in 1997?
Offer a terse response. 1.15. What is the ratio of the Employment (as % of male employment) of Agriculture in 1989 to that in 1990?
Provide a succinct answer. 1.36. What is the ratio of the Employment (as % of male employment) of Industry in 1989 to that in 1990?
Ensure brevity in your answer.  0.93. What is the ratio of the Employment (as % of male employment) in Services in 1989 to that in 1990?
Provide a short and direct response. 0.97. What is the ratio of the Employment (as % of male employment) of Self-employed in 1989 to that in 1990?
Offer a terse response. 1.04. What is the ratio of the Employment (as % of male employment) in Agriculture in 1989 to that in 1991?
Give a very brief answer. 1.03. What is the ratio of the Employment (as % of male employment) in Industry in 1989 to that in 1991?
Make the answer very short. 0.98. What is the ratio of the Employment (as % of male employment) of Self-employed in 1989 to that in 1991?
Your answer should be very brief. 1.1. What is the ratio of the Employment (as % of male employment) in Agriculture in 1989 to that in 1992?
Make the answer very short. 0.32. What is the ratio of the Employment (as % of male employment) of Industry in 1989 to that in 1992?
Offer a very short reply. 1.41. What is the ratio of the Employment (as % of male employment) in Services in 1989 to that in 1992?
Offer a very short reply. 1.78. What is the ratio of the Employment (as % of male employment) of Agriculture in 1989 to that in 1994?
Make the answer very short. 0.38. What is the ratio of the Employment (as % of male employment) in Industry in 1989 to that in 1994?
Ensure brevity in your answer.  1.25. What is the ratio of the Employment (as % of male employment) of Services in 1989 to that in 1994?
Offer a very short reply. 1.54. What is the ratio of the Employment (as % of male employment) in Self-employed in 1989 to that in 1994?
Provide a short and direct response. 1.01. What is the ratio of the Employment (as % of male employment) of Agriculture in 1989 to that in 1995?
Your response must be concise. 0.4. What is the ratio of the Employment (as % of male employment) of Industry in 1989 to that in 1995?
Provide a short and direct response. 1.21. What is the ratio of the Employment (as % of male employment) in Services in 1989 to that in 1995?
Offer a very short reply. 1.51. What is the ratio of the Employment (as % of male employment) of Self-employed in 1989 to that in 1995?
Make the answer very short. 0.98. What is the ratio of the Employment (as % of male employment) of Agriculture in 1989 to that in 1996?
Provide a short and direct response. 0.38. What is the ratio of the Employment (as % of male employment) of Industry in 1989 to that in 1996?
Your answer should be compact. 1.27. What is the ratio of the Employment (as % of male employment) in Services in 1989 to that in 1996?
Provide a short and direct response. 1.52. What is the ratio of the Employment (as % of male employment) of Agriculture in 1989 to that in 1997?
Make the answer very short. 0.4. What is the ratio of the Employment (as % of male employment) in Industry in 1989 to that in 1997?
Provide a succinct answer. 1.28. What is the ratio of the Employment (as % of male employment) in Services in 1989 to that in 1997?
Your answer should be compact. 1.43. What is the ratio of the Employment (as % of male employment) of Self-employed in 1989 to that in 1997?
Provide a succinct answer. 1.14. What is the ratio of the Employment (as % of male employment) in Agriculture in 1990 to that in 1991?
Your response must be concise. 0.76. What is the ratio of the Employment (as % of male employment) of Industry in 1990 to that in 1991?
Make the answer very short. 1.05. What is the ratio of the Employment (as % of male employment) of Services in 1990 to that in 1991?
Give a very brief answer. 1.03. What is the ratio of the Employment (as % of male employment) in Self-employed in 1990 to that in 1991?
Ensure brevity in your answer.  1.06. What is the ratio of the Employment (as % of male employment) of Agriculture in 1990 to that in 1992?
Give a very brief answer. 0.24. What is the ratio of the Employment (as % of male employment) in Industry in 1990 to that in 1992?
Make the answer very short. 1.52. What is the ratio of the Employment (as % of male employment) in Services in 1990 to that in 1992?
Your response must be concise. 1.84. What is the ratio of the Employment (as % of male employment) in Self-employed in 1990 to that in 1992?
Your answer should be compact. 0.96. What is the ratio of the Employment (as % of male employment) in Agriculture in 1990 to that in 1994?
Your response must be concise. 0.28. What is the ratio of the Employment (as % of male employment) of Industry in 1990 to that in 1994?
Give a very brief answer. 1.35. What is the ratio of the Employment (as % of male employment) of Services in 1990 to that in 1994?
Offer a terse response. 1.59. What is the ratio of the Employment (as % of male employment) of Self-employed in 1990 to that in 1994?
Provide a short and direct response. 0.97. What is the ratio of the Employment (as % of male employment) of Agriculture in 1990 to that in 1995?
Make the answer very short. 0.29. What is the ratio of the Employment (as % of male employment) in Industry in 1990 to that in 1995?
Give a very brief answer. 1.3. What is the ratio of the Employment (as % of male employment) in Services in 1990 to that in 1995?
Provide a short and direct response. 1.56. What is the ratio of the Employment (as % of male employment) of Self-employed in 1990 to that in 1995?
Your answer should be compact. 0.95. What is the ratio of the Employment (as % of male employment) of Agriculture in 1990 to that in 1996?
Offer a very short reply. 0.28. What is the ratio of the Employment (as % of male employment) of Industry in 1990 to that in 1996?
Make the answer very short. 1.37. What is the ratio of the Employment (as % of male employment) in Services in 1990 to that in 1996?
Offer a very short reply. 1.57. What is the ratio of the Employment (as % of male employment) of Self-employed in 1990 to that in 1996?
Make the answer very short. 1.02. What is the ratio of the Employment (as % of male employment) of Agriculture in 1990 to that in 1997?
Provide a short and direct response. 0.3. What is the ratio of the Employment (as % of male employment) of Industry in 1990 to that in 1997?
Your answer should be very brief. 1.37. What is the ratio of the Employment (as % of male employment) of Services in 1990 to that in 1997?
Offer a very short reply. 1.48. What is the ratio of the Employment (as % of male employment) in Self-employed in 1990 to that in 1997?
Ensure brevity in your answer.  1.1. What is the ratio of the Employment (as % of male employment) of Agriculture in 1991 to that in 1992?
Provide a succinct answer. 0.31. What is the ratio of the Employment (as % of male employment) of Industry in 1991 to that in 1992?
Keep it short and to the point. 1.44. What is the ratio of the Employment (as % of male employment) in Services in 1991 to that in 1992?
Your response must be concise. 1.78. What is the ratio of the Employment (as % of male employment) of Self-employed in 1991 to that in 1992?
Provide a short and direct response. 0.91. What is the ratio of the Employment (as % of male employment) in Agriculture in 1991 to that in 1994?
Your answer should be compact. 0.37. What is the ratio of the Employment (as % of male employment) in Industry in 1991 to that in 1994?
Provide a short and direct response. 1.28. What is the ratio of the Employment (as % of male employment) in Services in 1991 to that in 1994?
Offer a terse response. 1.54. What is the ratio of the Employment (as % of male employment) of Self-employed in 1991 to that in 1994?
Provide a short and direct response. 0.92. What is the ratio of the Employment (as % of male employment) of Agriculture in 1991 to that in 1995?
Your answer should be very brief. 0.39. What is the ratio of the Employment (as % of male employment) in Industry in 1991 to that in 1995?
Give a very brief answer. 1.23. What is the ratio of the Employment (as % of male employment) in Services in 1991 to that in 1995?
Your answer should be very brief. 1.51. What is the ratio of the Employment (as % of male employment) of Self-employed in 1991 to that in 1995?
Offer a very short reply. 0.89. What is the ratio of the Employment (as % of male employment) in Agriculture in 1991 to that in 1996?
Provide a short and direct response. 0.37. What is the ratio of the Employment (as % of male employment) in Industry in 1991 to that in 1996?
Give a very brief answer. 1.3. What is the ratio of the Employment (as % of male employment) of Services in 1991 to that in 1996?
Keep it short and to the point. 1.52. What is the ratio of the Employment (as % of male employment) in Self-employed in 1991 to that in 1996?
Offer a terse response. 0.97. What is the ratio of the Employment (as % of male employment) of Agriculture in 1991 to that in 1997?
Your answer should be very brief. 0.39. What is the ratio of the Employment (as % of male employment) in Industry in 1991 to that in 1997?
Ensure brevity in your answer.  1.3. What is the ratio of the Employment (as % of male employment) in Services in 1991 to that in 1997?
Ensure brevity in your answer.  1.43. What is the ratio of the Employment (as % of male employment) in Self-employed in 1991 to that in 1997?
Offer a terse response. 1.03. What is the ratio of the Employment (as % of male employment) in Agriculture in 1992 to that in 1994?
Your response must be concise. 1.19. What is the ratio of the Employment (as % of male employment) of Industry in 1992 to that in 1994?
Ensure brevity in your answer.  0.89. What is the ratio of the Employment (as % of male employment) of Services in 1992 to that in 1994?
Keep it short and to the point. 0.86. What is the ratio of the Employment (as % of male employment) in Self-employed in 1992 to that in 1994?
Make the answer very short. 1.01. What is the ratio of the Employment (as % of male employment) in Agriculture in 1992 to that in 1995?
Provide a succinct answer. 1.24. What is the ratio of the Employment (as % of male employment) in Industry in 1992 to that in 1995?
Your response must be concise. 0.86. What is the ratio of the Employment (as % of male employment) of Services in 1992 to that in 1995?
Keep it short and to the point. 0.85. What is the ratio of the Employment (as % of male employment) of Self-employed in 1992 to that in 1995?
Your answer should be compact. 0.99. What is the ratio of the Employment (as % of male employment) in Agriculture in 1992 to that in 1996?
Provide a short and direct response. 1.19. What is the ratio of the Employment (as % of male employment) of Industry in 1992 to that in 1996?
Your answer should be very brief. 0.9. What is the ratio of the Employment (as % of male employment) of Services in 1992 to that in 1996?
Provide a succinct answer. 0.85. What is the ratio of the Employment (as % of male employment) of Self-employed in 1992 to that in 1996?
Ensure brevity in your answer.  1.07. What is the ratio of the Employment (as % of male employment) in Agriculture in 1992 to that in 1997?
Your response must be concise. 1.25. What is the ratio of the Employment (as % of male employment) of Industry in 1992 to that in 1997?
Give a very brief answer. 0.9. What is the ratio of the Employment (as % of male employment) in Services in 1992 to that in 1997?
Offer a very short reply. 0.8. What is the ratio of the Employment (as % of male employment) in Self-employed in 1992 to that in 1997?
Offer a terse response. 1.14. What is the ratio of the Employment (as % of male employment) of Agriculture in 1994 to that in 1995?
Give a very brief answer. 1.04. What is the ratio of the Employment (as % of male employment) of Industry in 1994 to that in 1995?
Provide a succinct answer. 0.97. What is the ratio of the Employment (as % of male employment) of Services in 1994 to that in 1995?
Provide a succinct answer. 0.98. What is the ratio of the Employment (as % of male employment) in Self-employed in 1994 to that in 1995?
Give a very brief answer. 0.98. What is the ratio of the Employment (as % of male employment) of Agriculture in 1994 to that in 1996?
Give a very brief answer. 1. What is the ratio of the Employment (as % of male employment) of Industry in 1994 to that in 1996?
Give a very brief answer. 1.02. What is the ratio of the Employment (as % of male employment) of Services in 1994 to that in 1996?
Offer a very short reply. 0.99. What is the ratio of the Employment (as % of male employment) in Self-employed in 1994 to that in 1996?
Your answer should be very brief. 1.06. What is the ratio of the Employment (as % of male employment) of Agriculture in 1994 to that in 1997?
Your answer should be very brief. 1.06. What is the ratio of the Employment (as % of male employment) of Industry in 1994 to that in 1997?
Your response must be concise. 1.02. What is the ratio of the Employment (as % of male employment) of Services in 1994 to that in 1997?
Your answer should be compact. 0.93. What is the ratio of the Employment (as % of male employment) in Self-employed in 1994 to that in 1997?
Your response must be concise. 1.13. What is the ratio of the Employment (as % of male employment) in Agriculture in 1995 to that in 1996?
Offer a very short reply. 0.96. What is the ratio of the Employment (as % of male employment) of Industry in 1995 to that in 1996?
Make the answer very short. 1.05. What is the ratio of the Employment (as % of male employment) in Services in 1995 to that in 1996?
Your answer should be very brief. 1.01. What is the ratio of the Employment (as % of male employment) in Self-employed in 1995 to that in 1996?
Keep it short and to the point. 1.08. What is the ratio of the Employment (as % of male employment) in Agriculture in 1995 to that in 1997?
Provide a short and direct response. 1.02. What is the ratio of the Employment (as % of male employment) in Industry in 1995 to that in 1997?
Your answer should be compact. 1.06. What is the ratio of the Employment (as % of male employment) of Services in 1995 to that in 1997?
Keep it short and to the point. 0.95. What is the ratio of the Employment (as % of male employment) in Self-employed in 1995 to that in 1997?
Offer a terse response. 1.16. What is the ratio of the Employment (as % of male employment) in Agriculture in 1996 to that in 1997?
Your answer should be very brief. 1.06. What is the ratio of the Employment (as % of male employment) of Industry in 1996 to that in 1997?
Your answer should be compact. 1. What is the ratio of the Employment (as % of male employment) of Services in 1996 to that in 1997?
Give a very brief answer. 0.94. What is the ratio of the Employment (as % of male employment) of Self-employed in 1996 to that in 1997?
Ensure brevity in your answer.  1.07. What is the difference between the highest and the second highest Employment (as % of male employment) in Industry?
Your response must be concise. 0.1. What is the difference between the highest and the second highest Employment (as % of male employment) in Self-employed?
Keep it short and to the point. 0.3. What is the difference between the highest and the lowest Employment (as % of male employment) of Agriculture?
Provide a short and direct response. 36.5. What is the difference between the highest and the lowest Employment (as % of male employment) in Services?
Offer a terse response. 24.7. 